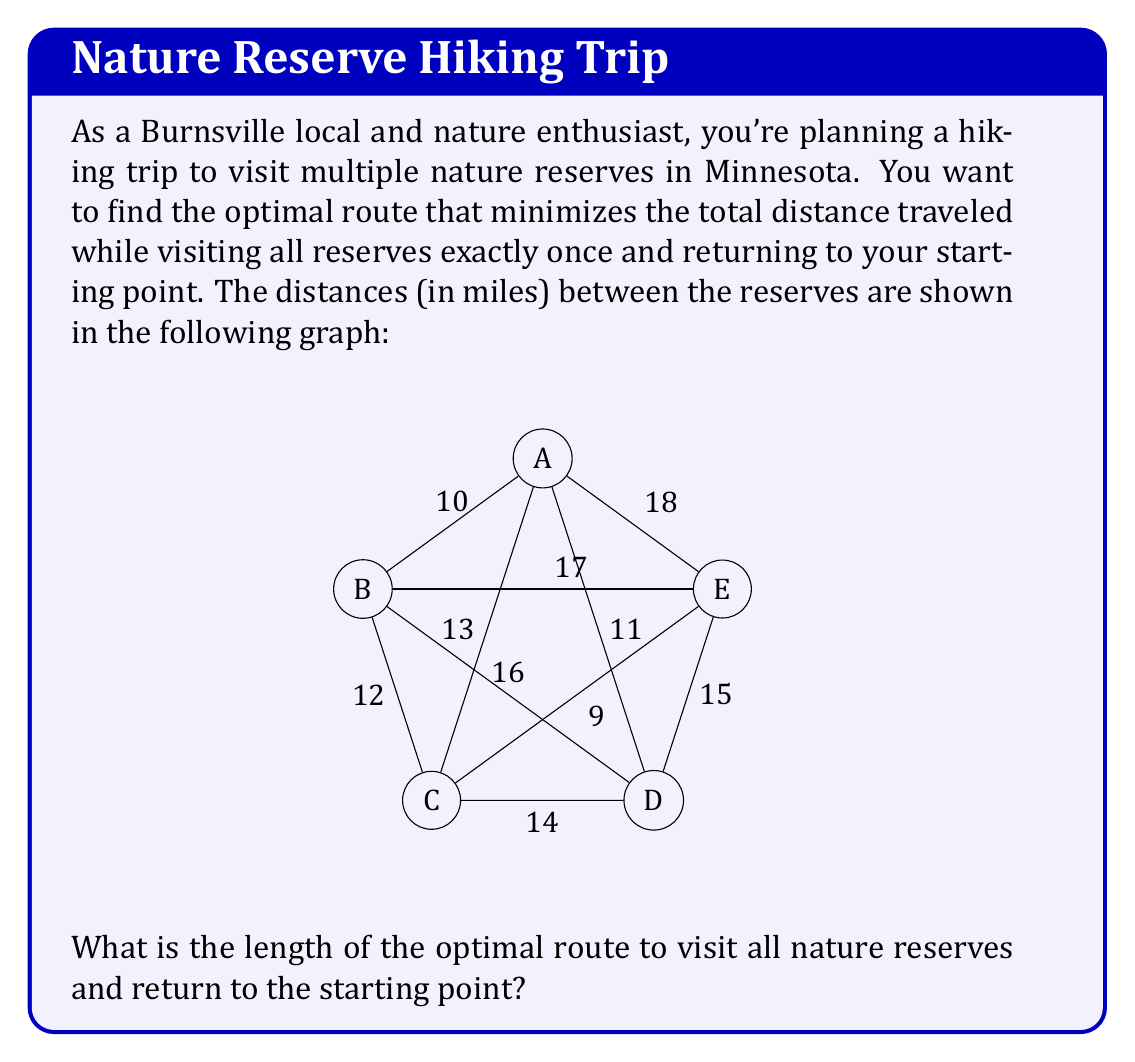Can you answer this question? To solve this problem, we need to find the shortest Hamiltonian cycle in the given graph, which is known as the Traveling Salesman Problem (TSP). For a small graph like this, we can use the following steps:

1) List all possible Hamiltonian cycles:
   There are $(5-1)!/2 = 12$ possible cycles, considering that the start/end point doesn't matter and the direction can be reversed.

2) Calculate the length of each cycle:
   ABCDEA: 15 + 12 + 10 + 14 + 18 = 69
   ABCEDA: 15 + 12 + 9 + 14 + 18 = 68
   ABDCEA: 15 + 16 + 10 + 9 + 18 = 68
   ABDECA: 15 + 16 + 14 + 9 + 13 = 67
   ABECDA: 15 + 17 + 9 + 10 + 11 = 62
   ABEDCA: 15 + 17 + 14 + 10 + 13 = 69
   ACBDEA: 13 + 12 + 16 + 14 + 18 = 73
   ACBEDA: 13 + 12 + 17 + 14 + 11 = 67
   ACDEBA: 13 + 10 + 14 + 17 + 15 = 69
   ADCBEA: 11 + 10 + 12 + 17 + 18 = 68
   ADEBCA: 11 + 14 + 17 + 12 + 13 = 67
   AEDCBA: 18 + 14 + 10 + 12 + 15 = 69

3) Identify the shortest cycle:
   The shortest cycle is ABECDA with a total length of 62 miles.

Therefore, the optimal route is A → B → E → C → D → A, or any cyclic permutation or reversal of this order.
Answer: 62 miles 